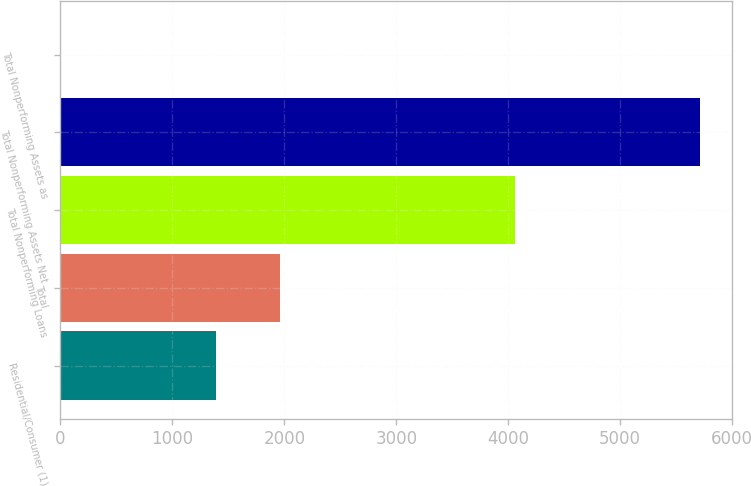Convert chart to OTSL. <chart><loc_0><loc_0><loc_500><loc_500><bar_chart><fcel>Residential/Consumer (1)<fcel>Total<fcel>Total Nonperforming Loans<fcel>Total Nonperforming Assets Net<fcel>Total Nonperforming Assets as<nl><fcel>1391<fcel>1962.79<fcel>4065<fcel>5718<fcel>0.12<nl></chart> 